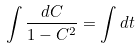<formula> <loc_0><loc_0><loc_500><loc_500>\int \frac { d C } { 1 - C ^ { 2 } } = \int d t</formula> 